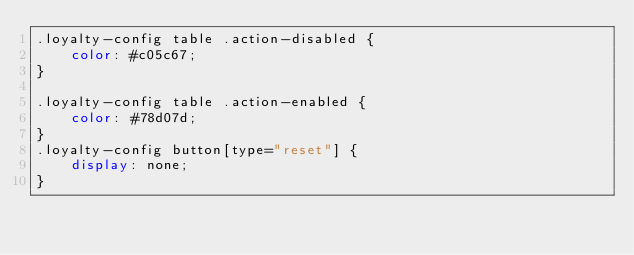Convert code to text. <code><loc_0><loc_0><loc_500><loc_500><_CSS_>.loyalty-config table .action-disabled {
    color: #c05c67;
}

.loyalty-config table .action-enabled {
    color: #78d07d;
}
.loyalty-config button[type="reset"] {
    display: none;
}</code> 